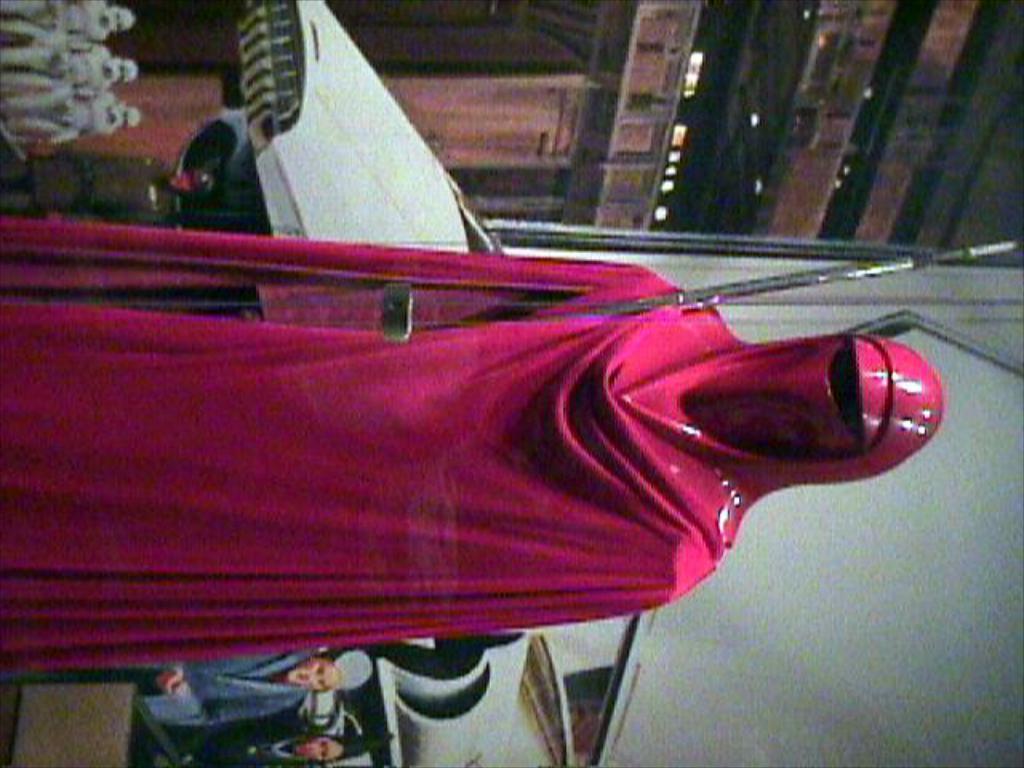Please provide a concise description of this image. This image is in right direction. Here I can see a person wearing a pink color costume and standing. In the background, I can see a photo of few people. At the top there is a building and I can see three persons are standing. This is looking like an edited image. 